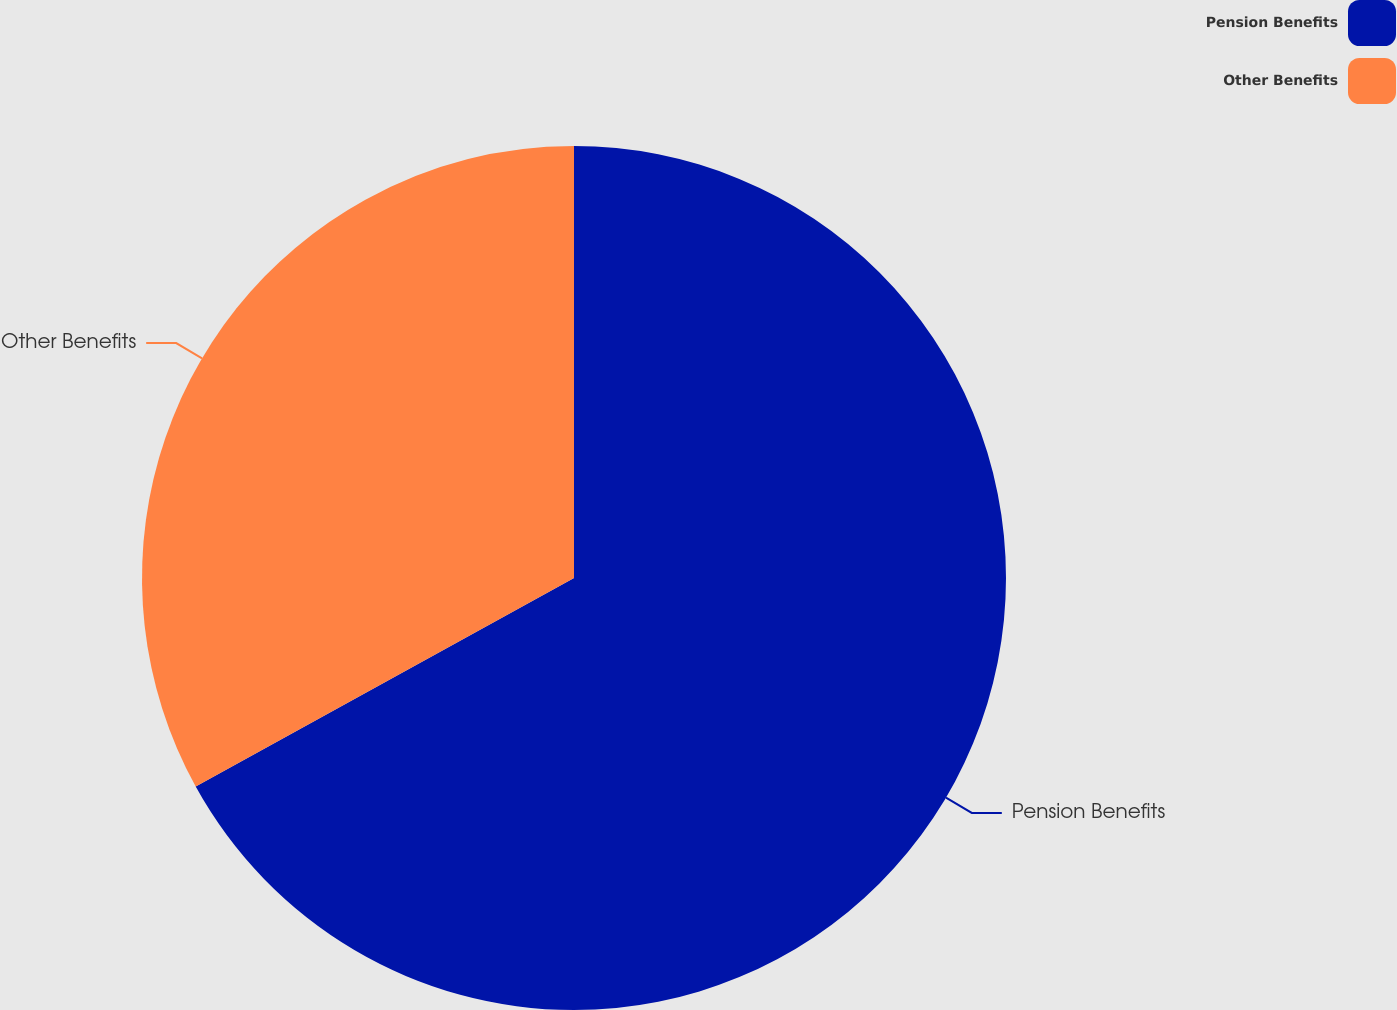Convert chart. <chart><loc_0><loc_0><loc_500><loc_500><pie_chart><fcel>Pension Benefits<fcel>Other Benefits<nl><fcel>66.98%<fcel>33.02%<nl></chart> 